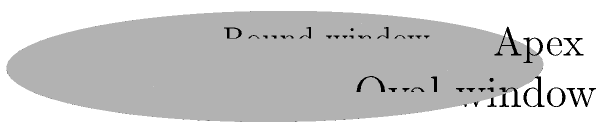Based on the 3D model of the cochlea shown above, if you were to rotate the view 90 degrees clockwise around the vertical axis, which labeled structure would appear closest to you? To solve this question, let's follow these steps:

1. Understand the current view:
   - The model shows a 3D representation of the cochlea.
   - The apex is at the top, and the base is at the bottom.
   - The round window is on the left, and the oval window is on the right.

2. Visualize the rotation:
   - We need to imagine rotating the view 90 degrees clockwise around the vertical axis.
   - This means we'll be looking at the cochlea from the right side of the current view.

3. Analyze the new perspective:
   - After rotation, the oval window, which is currently on the right, would be facing us.
   - The round window, currently on the left, would move to the back.
   - The apex and base would remain in their vertical positions.

4. Determine the closest structure:
   - In the new perspective, the oval window would be the labeled structure appearing closest to the viewer.

Therefore, after the 90-degree clockwise rotation around the vertical axis, the oval window would be the labeled structure closest to the observer.
Answer: Oval window 